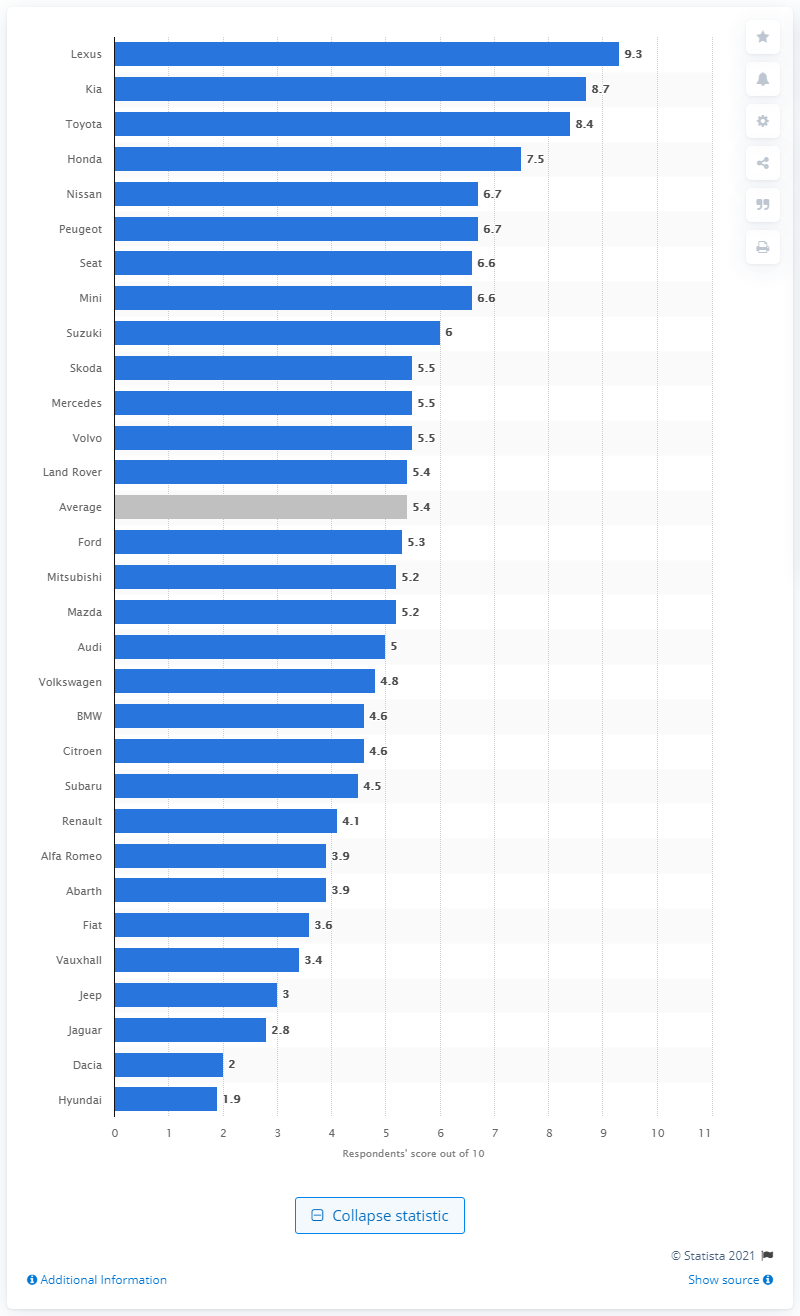Indicate a few pertinent items in this graphic. Lexus is the car dealer that gave a score of 9.3 out of 10. Lexus dealer satisfaction was rated at 9.3 out of 10. 